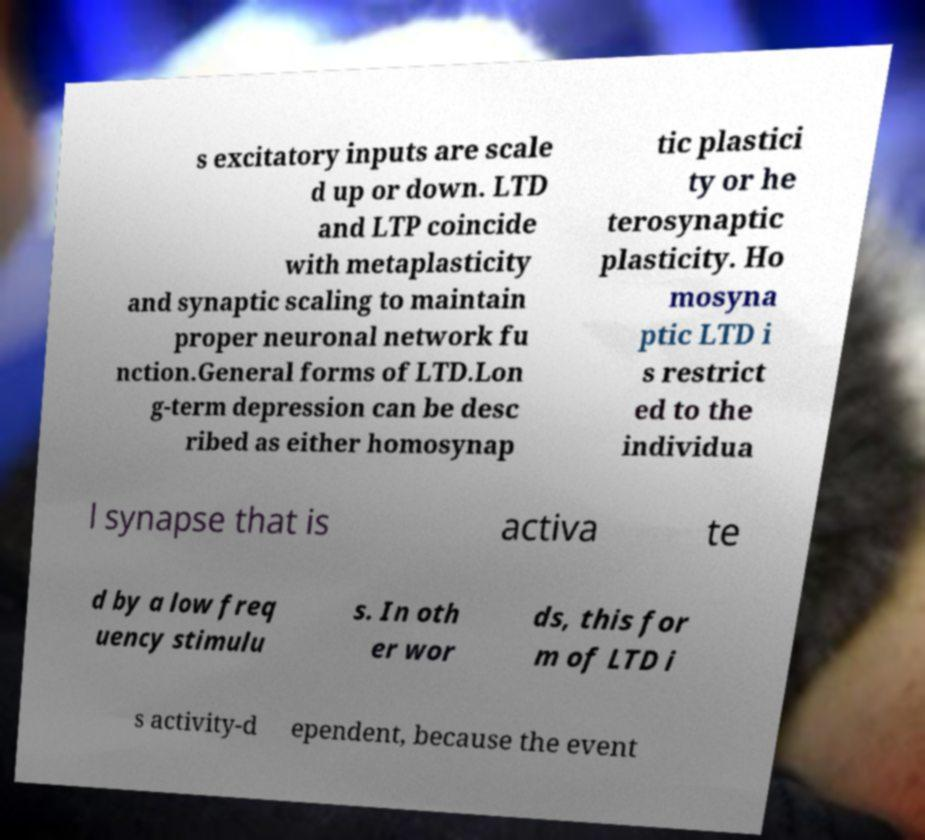Can you read and provide the text displayed in the image?This photo seems to have some interesting text. Can you extract and type it out for me? s excitatory inputs are scale d up or down. LTD and LTP coincide with metaplasticity and synaptic scaling to maintain proper neuronal network fu nction.General forms of LTD.Lon g-term depression can be desc ribed as either homosynap tic plastici ty or he terosynaptic plasticity. Ho mosyna ptic LTD i s restrict ed to the individua l synapse that is activa te d by a low freq uency stimulu s. In oth er wor ds, this for m of LTD i s activity-d ependent, because the event 